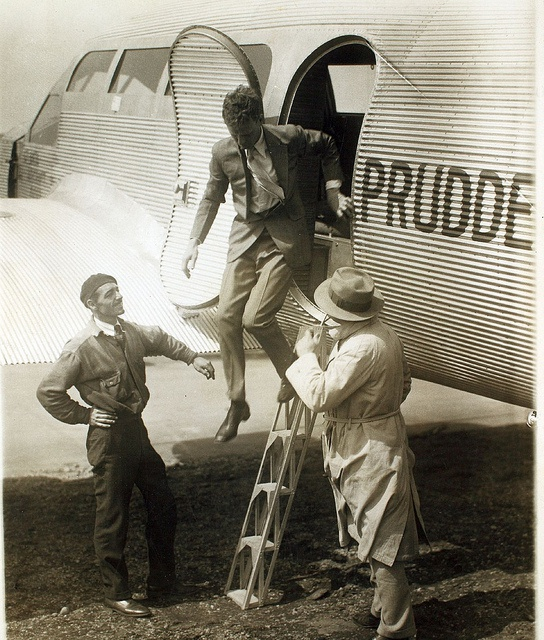Describe the objects in this image and their specific colors. I can see airplane in ivory, darkgray, lightgray, and black tones, people in ivory, black, gray, and lightgray tones, people in ivory, gray, and black tones, people in ivory, black, gray, darkgreen, and darkgray tones, and tie in ivory, gray, darkgray, and black tones in this image. 